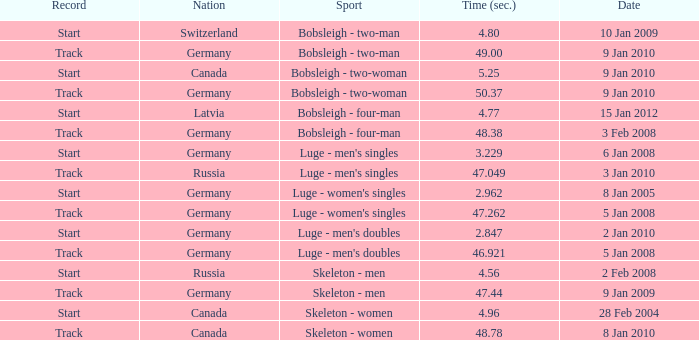Which nation had a time of 48.38? Germany. 